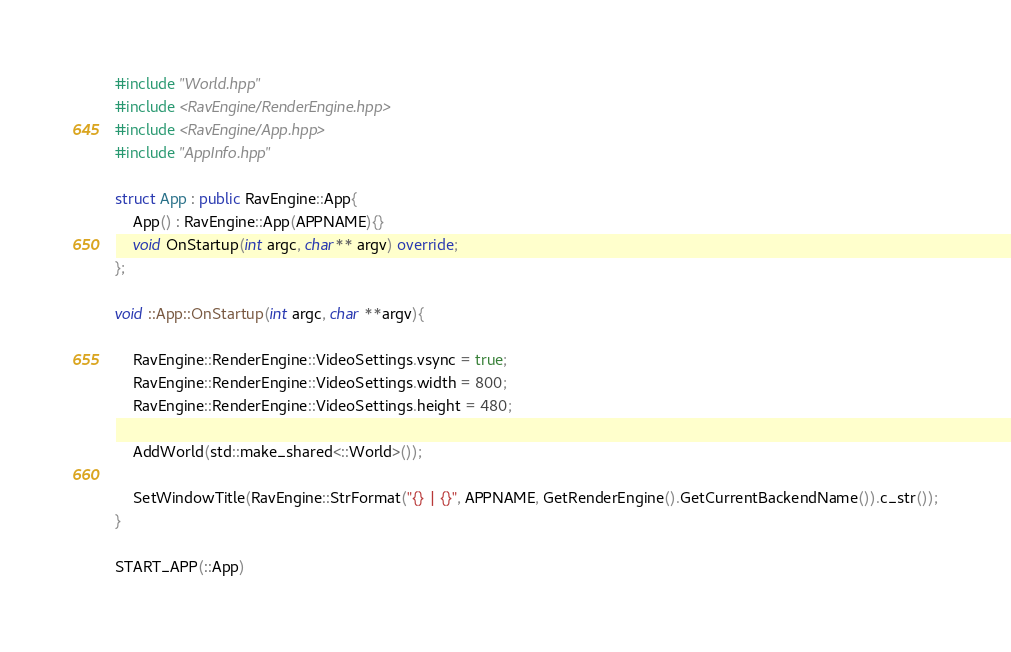<code> <loc_0><loc_0><loc_500><loc_500><_C++_>#include "World.hpp"
#include <RavEngine/RenderEngine.hpp>
#include <RavEngine/App.hpp>
#include "AppInfo.hpp"

struct App : public RavEngine::App{
	App() : RavEngine::App(APPNAME){}
	void OnStartup(int argc, char** argv) override;
};

void ::App::OnStartup(int argc, char **argv){
	
	RavEngine::RenderEngine::VideoSettings.vsync = true;
	RavEngine::RenderEngine::VideoSettings.width = 800;
	RavEngine::RenderEngine::VideoSettings.height = 480;
		
	AddWorld(std::make_shared<::World>());
	
	SetWindowTitle(RavEngine::StrFormat("{} | {}", APPNAME, GetRenderEngine().GetCurrentBackendName()).c_str());
}

START_APP(::App)
</code> 